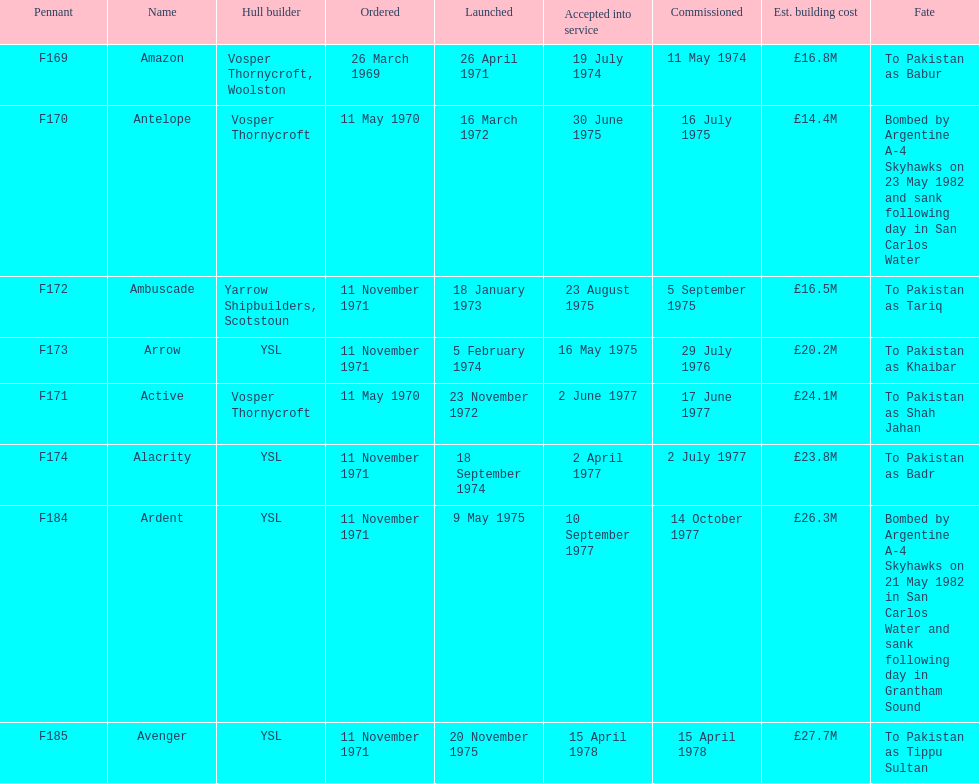How many ships were laid down in september? 2. 